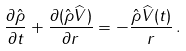<formula> <loc_0><loc_0><loc_500><loc_500>\frac { \partial \hat { \rho } } { \partial t } + \frac { \partial ( \hat { \rho } \widehat { V } ) } { \partial r } = - \frac { \hat { \rho } \widehat { V } ( t ) } { r } \, .</formula> 